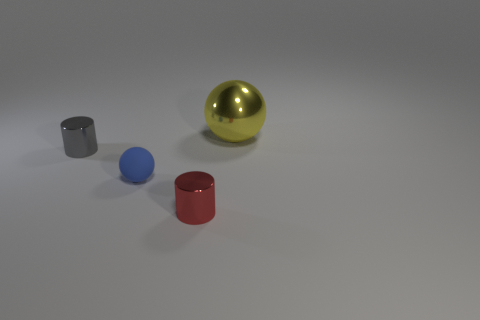The small gray shiny object has what shape?
Offer a terse response. Cylinder. What color is the object that is on the left side of the tiny red metallic object and in front of the small gray metal cylinder?
Provide a succinct answer. Blue. What is the tiny blue thing made of?
Make the answer very short. Rubber. What is the shape of the small metallic thing in front of the gray metallic object?
Your response must be concise. Cylinder. There is a rubber ball that is the same size as the red shiny cylinder; what is its color?
Ensure brevity in your answer.  Blue. Do the thing that is right of the red cylinder and the small blue sphere have the same material?
Your response must be concise. No. How big is the metal thing that is both behind the tiny blue ball and right of the matte ball?
Provide a short and direct response. Large. There is a sphere that is on the right side of the red thing; how big is it?
Offer a very short reply. Large. What shape is the object that is behind the shiny cylinder that is behind the small cylinder that is right of the tiny gray metallic cylinder?
Your answer should be compact. Sphere. How many other things are the same shape as the small matte object?
Offer a very short reply. 1. 